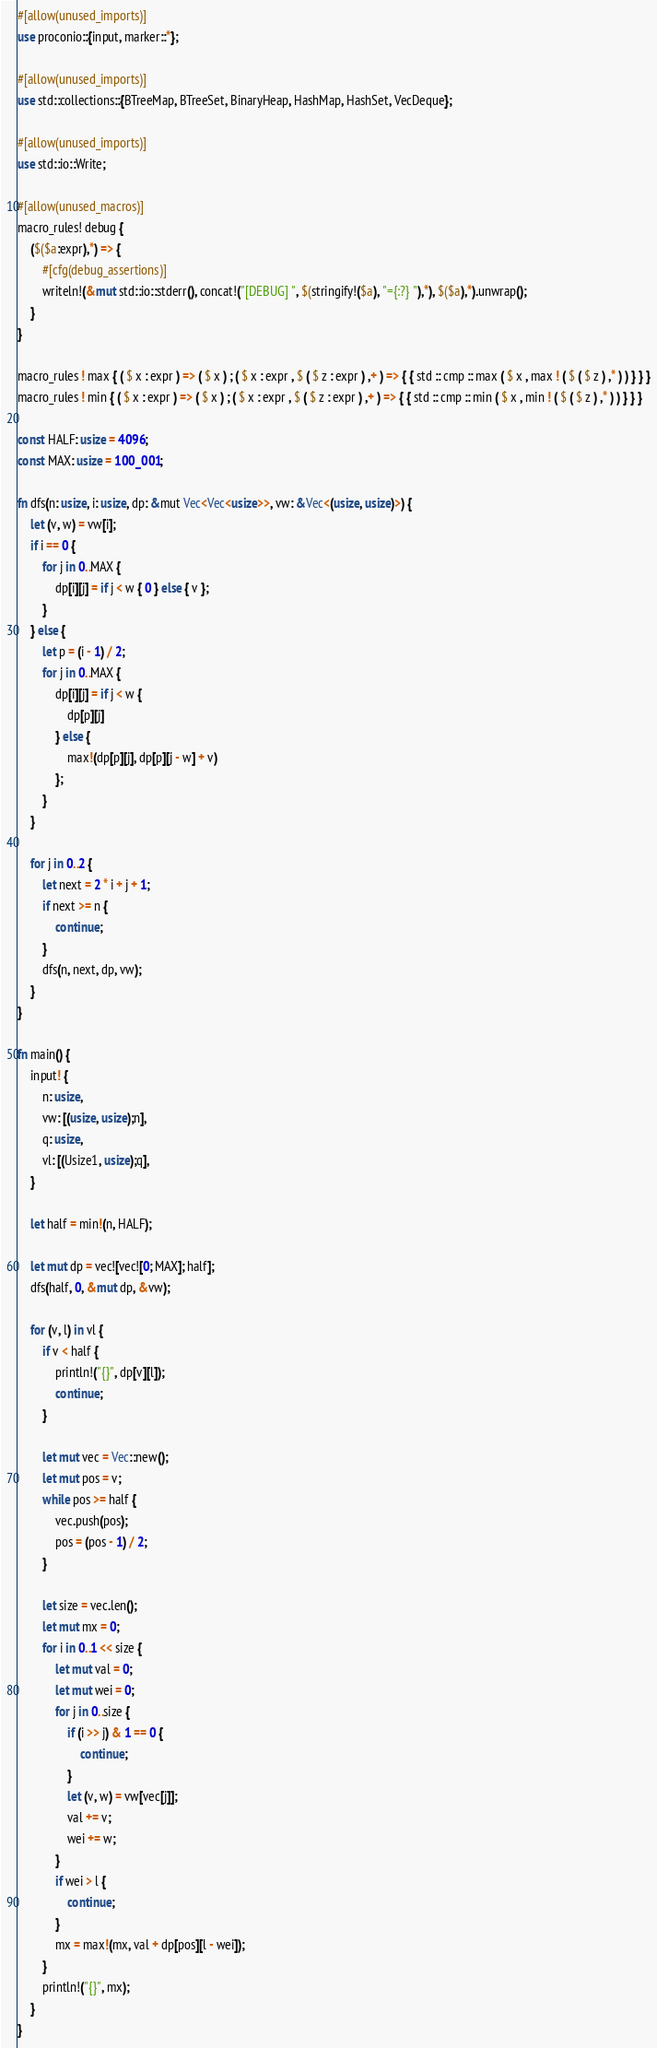<code> <loc_0><loc_0><loc_500><loc_500><_Rust_>#[allow(unused_imports)]
use proconio::{input, marker::*};

#[allow(unused_imports)]
use std::collections::{BTreeMap, BTreeSet, BinaryHeap, HashMap, HashSet, VecDeque};

#[allow(unused_imports)]
use std::io::Write;

#[allow(unused_macros)]
macro_rules! debug {
    ($($a:expr),*) => {
        #[cfg(debug_assertions)]
        writeln!(&mut std::io::stderr(), concat!("[DEBUG] ", $(stringify!($a), "={:?} "),*), $($a),*).unwrap();
    }
}

macro_rules ! max { ( $ x : expr ) => ( $ x ) ; ( $ x : expr , $ ( $ z : expr ) ,+ ) => { { std :: cmp :: max ( $ x , max ! ( $ ( $ z ) ,* ) ) } } }
macro_rules ! min { ( $ x : expr ) => ( $ x ) ; ( $ x : expr , $ ( $ z : expr ) ,+ ) => { { std :: cmp :: min ( $ x , min ! ( $ ( $ z ) ,* ) ) } } }

const HALF: usize = 4096;
const MAX: usize = 100_001;

fn dfs(n: usize, i: usize, dp: &mut Vec<Vec<usize>>, vw: &Vec<(usize, usize)>) {
    let (v, w) = vw[i];
    if i == 0 {
        for j in 0..MAX {
            dp[i][j] = if j < w { 0 } else { v };
        }
    } else {
        let p = (i - 1) / 2;
        for j in 0..MAX {
            dp[i][j] = if j < w {
                dp[p][j]
            } else {
                max!(dp[p][j], dp[p][j - w] + v)
            };
        }
    }

    for j in 0..2 {
        let next = 2 * i + j + 1;
        if next >= n {
            continue;
        }
        dfs(n, next, dp, vw);
    }
}

fn main() {
    input! {
        n: usize,
        vw: [(usize, usize);n],
        q: usize,
        vl: [(Usize1, usize);q],
    }

    let half = min!(n, HALF);

    let mut dp = vec![vec![0; MAX]; half];
    dfs(half, 0, &mut dp, &vw);

    for (v, l) in vl {
        if v < half {
            println!("{}", dp[v][l]);
            continue;
        }

        let mut vec = Vec::new();
        let mut pos = v;
        while pos >= half {
            vec.push(pos);
            pos = (pos - 1) / 2;
        }

        let size = vec.len();
        let mut mx = 0;
        for i in 0..1 << size {
            let mut val = 0;
            let mut wei = 0;
            for j in 0..size {
                if (i >> j) & 1 == 0 {
                    continue;
                }
                let (v, w) = vw[vec[j]];
                val += v;
                wei += w;
            }
            if wei > l {
                continue;
            }
            mx = max!(mx, val + dp[pos][l - wei]);
        }
        println!("{}", mx);
    }
}
</code> 